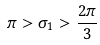Convert formula to latex. <formula><loc_0><loc_0><loc_500><loc_500>\pi > \sigma _ { 1 } > \frac { 2 \pi } { 3 }</formula> 